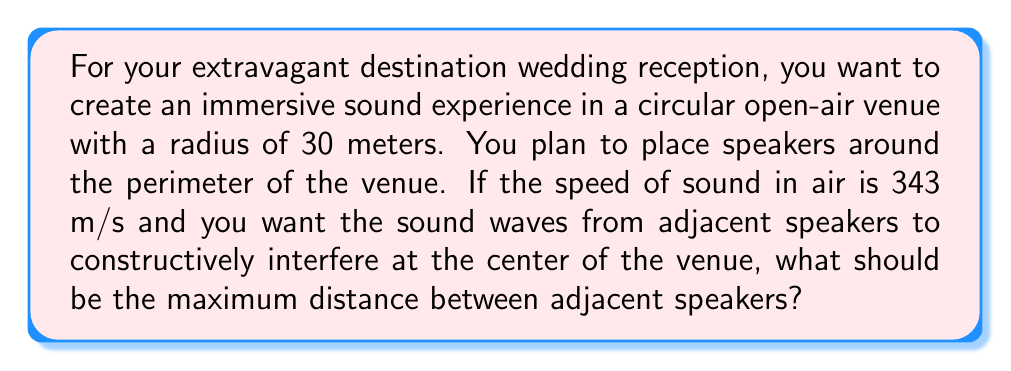Show me your answer to this math problem. To solve this problem, we need to consider the principles of constructive interference and circular wave propagation. Let's approach this step-by-step:

1) For constructive interference to occur at the center, the path difference between waves from adjacent speakers should be an integer multiple of the wavelength. Let's consider the case where it's exactly one wavelength.

2) The wavelength λ is related to the frequency f and speed of sound v by the equation:
   $v = f\lambda$

3) We don't know the frequency, but we can express the wavelength in terms of the arc length s between speakers:
   $\lambda = s$

4) In a circle, the arc length s is related to the central angle θ (in radians) and radius r by:
   $s = r\theta$

5) For the waves to arrive in phase at the center, the path difference must be λ:
   $2r - 2r\cos(\frac{\theta}{2}) = \lambda = s = r\theta$

6) This gives us the equation:
   $2 - 2\cos(\frac{\theta}{2}) = \theta$

7) This transcendental equation can be solved numerically. The solution is approximately:
   $\theta \approx 2.33104$ radians

8) Now we can calculate the arc length s:
   $s = r\theta = 30 \cdot 2.33104 \approx 69.9312$ meters

Therefore, the maximum distance between adjacent speakers should be approximately 69.93 meters.
Answer: 69.93 meters 